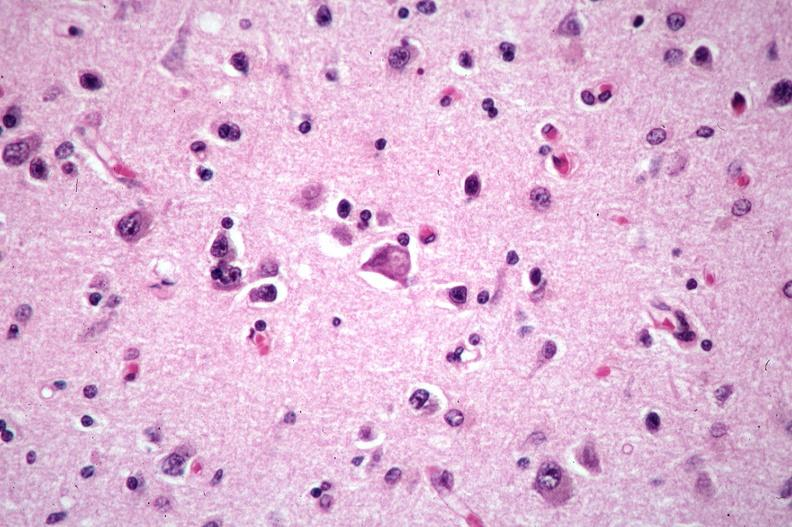s nervous present?
Answer the question using a single word or phrase. Yes 